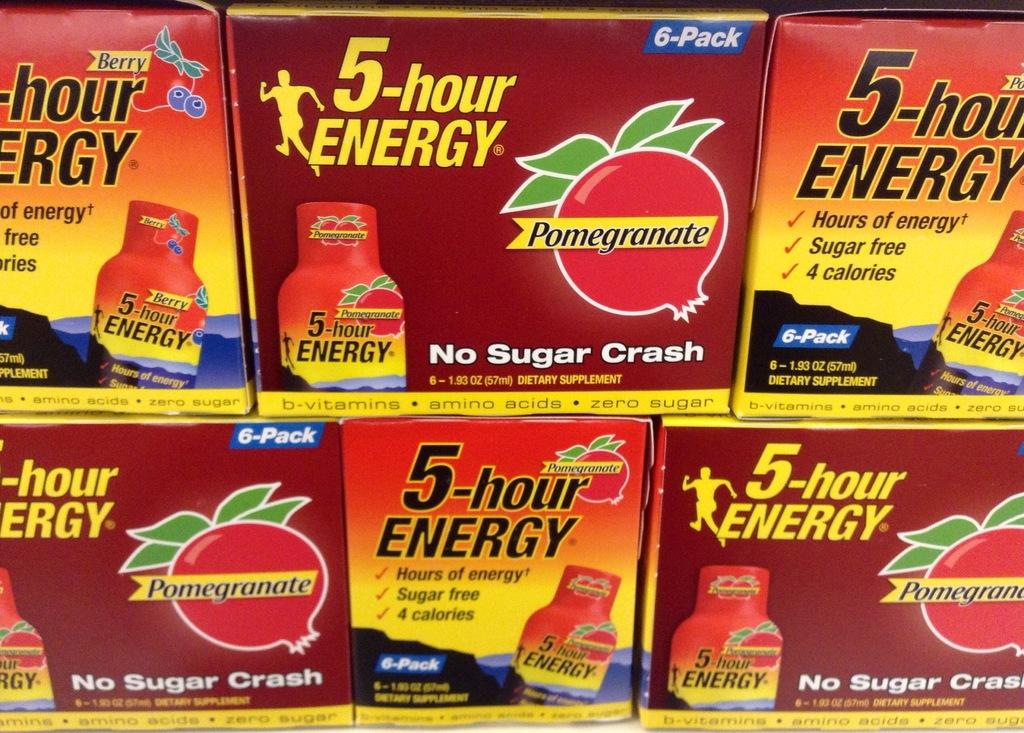<image>
Render a clear and concise summary of the photo. Packets of pomegranate and berry flavored 5-hour energy supplements are stacked on top of each other. 